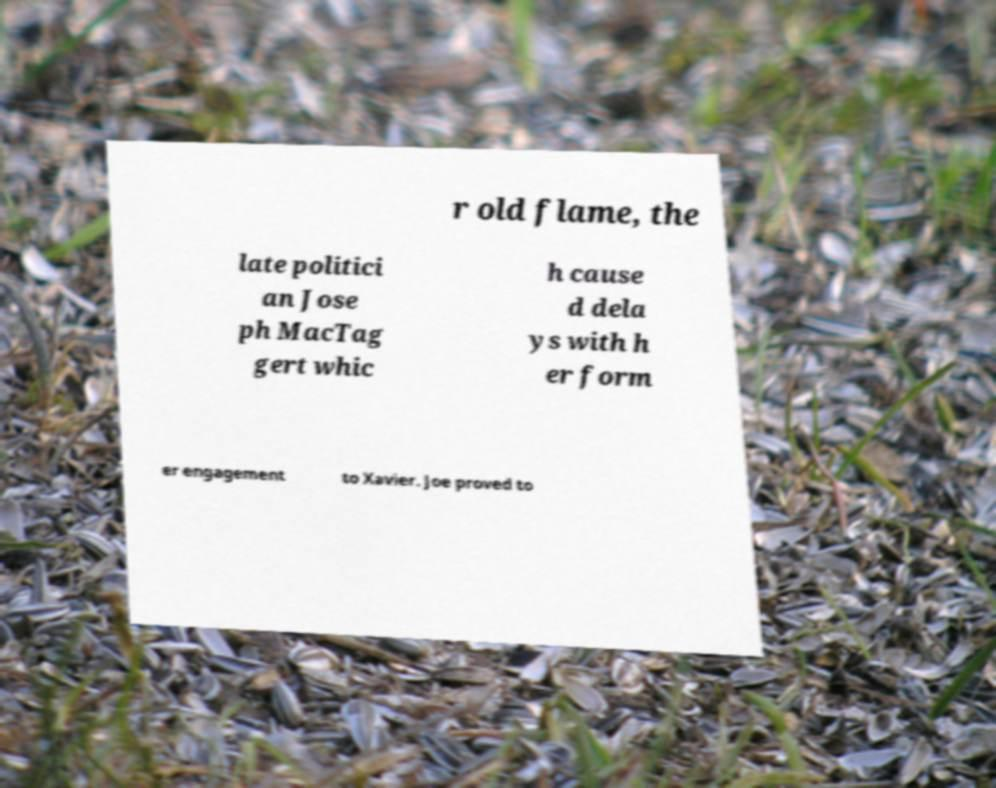Could you extract and type out the text from this image? r old flame, the late politici an Jose ph MacTag gert whic h cause d dela ys with h er form er engagement to Xavier. Joe proved to 